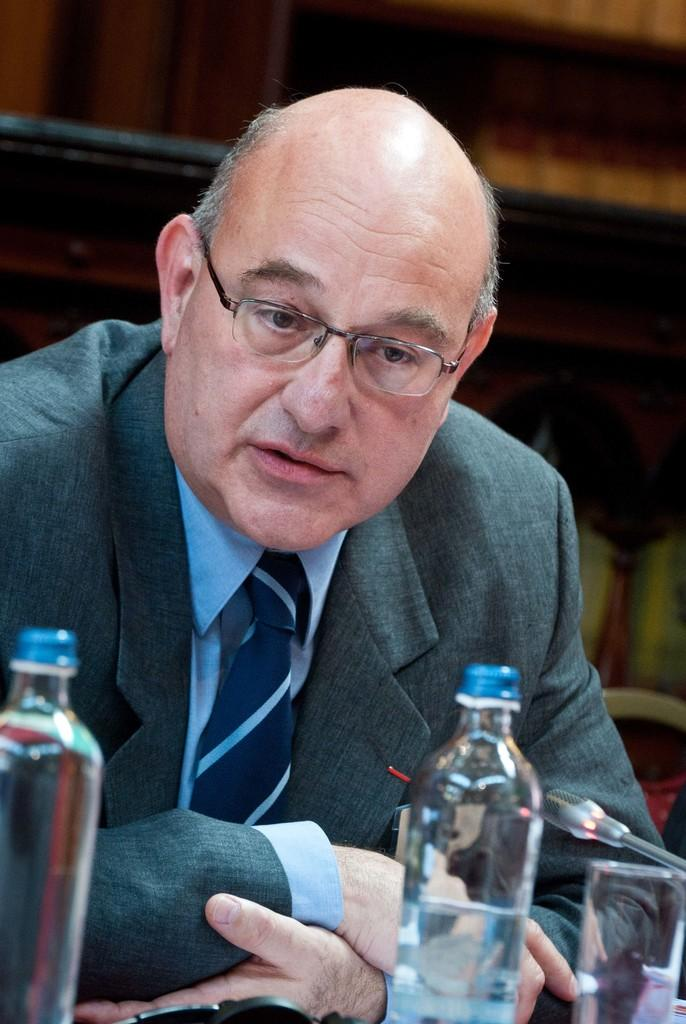What is the main subject of the image? The main subject of the image is a man. What is the man wearing on his upper body? The man is wearing a green blazer and a blue shirt. What accessory is the man wearing around his neck? The man is wearing a blue tie. What is the man wearing on his face to aid his vision? The man is wearing spectacles. What items are in front of the man? There are two water bottles in front of the man. What type of insurance policy does the man have in the image? There is no mention of insurance in the image, so it cannot be determined. Can you tell me how many kittens are sitting on the man's lap in the image? There are no kittens present in the image. 